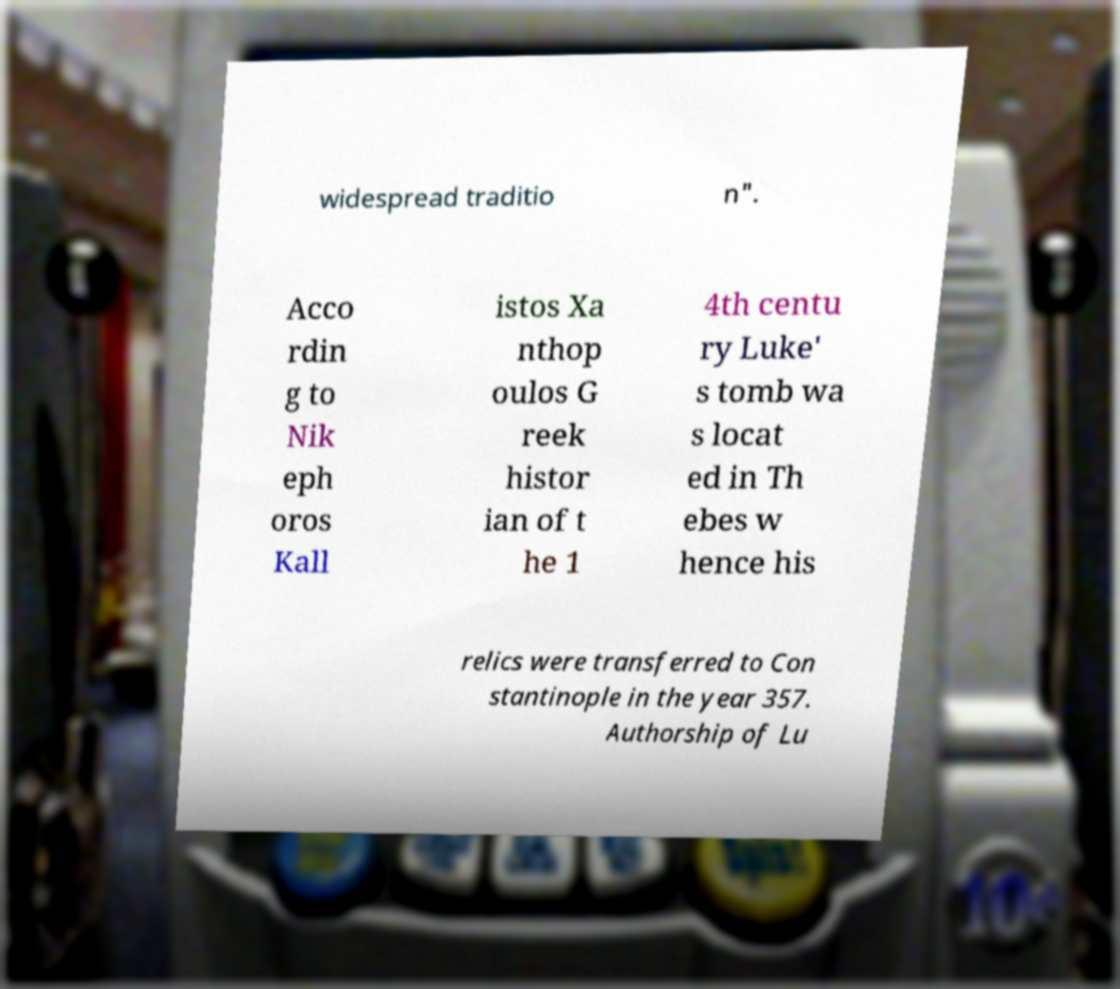Can you read and provide the text displayed in the image?This photo seems to have some interesting text. Can you extract and type it out for me? widespread traditio n". Acco rdin g to Nik eph oros Kall istos Xa nthop oulos G reek histor ian of t he 1 4th centu ry Luke' s tomb wa s locat ed in Th ebes w hence his relics were transferred to Con stantinople in the year 357. Authorship of Lu 